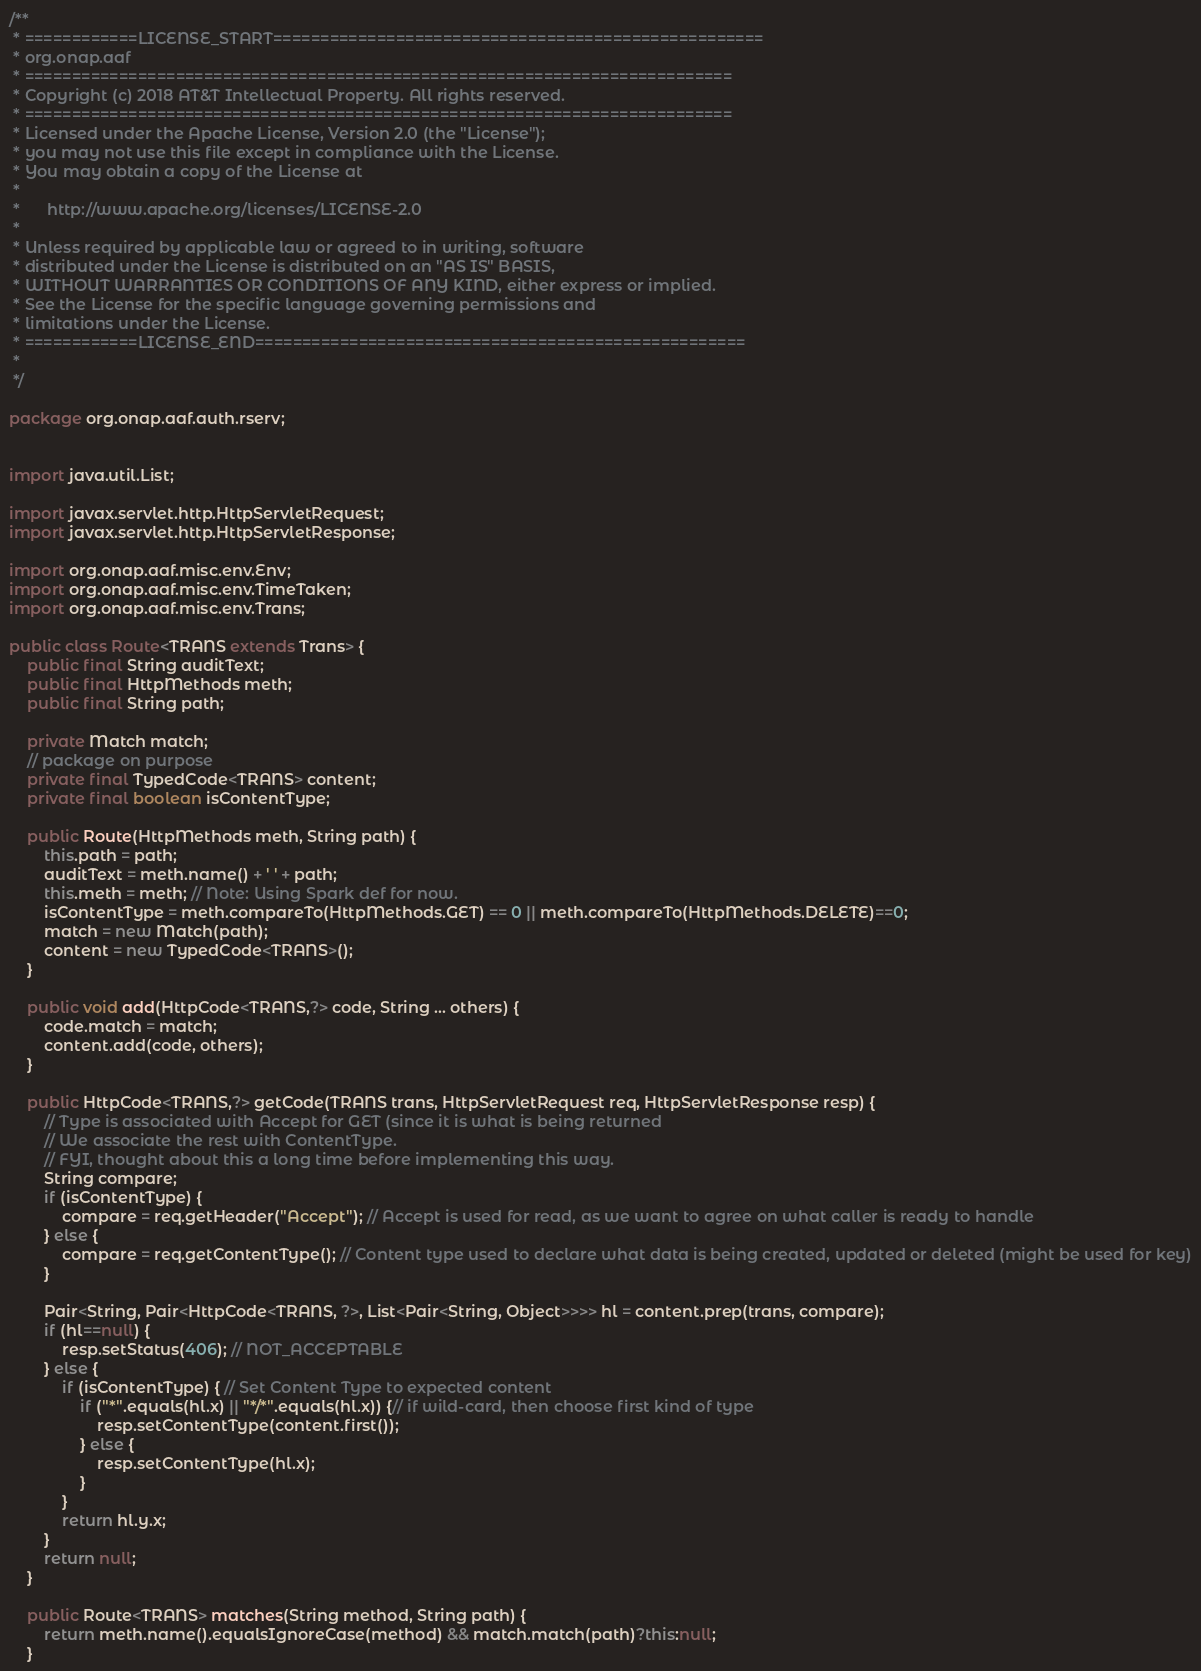<code> <loc_0><loc_0><loc_500><loc_500><_Java_>/**
 * ============LICENSE_START====================================================
 * org.onap.aaf
 * ===========================================================================
 * Copyright (c) 2018 AT&T Intellectual Property. All rights reserved.
 * ===========================================================================
 * Licensed under the Apache License, Version 2.0 (the "License");
 * you may not use this file except in compliance with the License.
 * You may obtain a copy of the License at
 *
 *      http://www.apache.org/licenses/LICENSE-2.0
 *
 * Unless required by applicable law or agreed to in writing, software
 * distributed under the License is distributed on an "AS IS" BASIS,
 * WITHOUT WARRANTIES OR CONDITIONS OF ANY KIND, either express or implied.
 * See the License for the specific language governing permissions and
 * limitations under the License.
 * ============LICENSE_END====================================================
 *
 */

package org.onap.aaf.auth.rserv;


import java.util.List;

import javax.servlet.http.HttpServletRequest;
import javax.servlet.http.HttpServletResponse;

import org.onap.aaf.misc.env.Env;
import org.onap.aaf.misc.env.TimeTaken;
import org.onap.aaf.misc.env.Trans;

public class Route<TRANS extends Trans> {
    public final String auditText;
    public final HttpMethods meth;
    public final String path;

    private Match match;
    // package on purpose
    private final TypedCode<TRANS> content;
    private final boolean isContentType;

    public Route(HttpMethods meth, String path) {
        this.path = path;
        auditText = meth.name() + ' ' + path;
        this.meth = meth; // Note: Using Spark def for now.
        isContentType = meth.compareTo(HttpMethods.GET) == 0 || meth.compareTo(HttpMethods.DELETE)==0;
        match = new Match(path);
        content = new TypedCode<TRANS>();
    }

    public void add(HttpCode<TRANS,?> code, String ... others) {
        code.match = match;
        content.add(code, others);
    }

    public HttpCode<TRANS,?> getCode(TRANS trans, HttpServletRequest req, HttpServletResponse resp) {
        // Type is associated with Accept for GET (since it is what is being returned
        // We associate the rest with ContentType.
        // FYI, thought about this a long time before implementing this way.
        String compare;
        if (isContentType) {
            compare = req.getHeader("Accept"); // Accept is used for read, as we want to agree on what caller is ready to handle
        } else {
            compare = req.getContentType(); // Content type used to declare what data is being created, updated or deleted (might be used for key)
        }

        Pair<String, Pair<HttpCode<TRANS, ?>, List<Pair<String, Object>>>> hl = content.prep(trans, compare);
        if (hl==null) {
            resp.setStatus(406); // NOT_ACCEPTABLE
        } else {
            if (isContentType) { // Set Content Type to expected content
                if ("*".equals(hl.x) || "*/*".equals(hl.x)) {// if wild-card, then choose first kind of type
                    resp.setContentType(content.first());
                } else {
                    resp.setContentType(hl.x);
                }
            }
            return hl.y.x;
        }
        return null;
    }

    public Route<TRANS> matches(String method, String path) {
        return meth.name().equalsIgnoreCase(method) && match.match(path)?this:null;
    }
</code> 